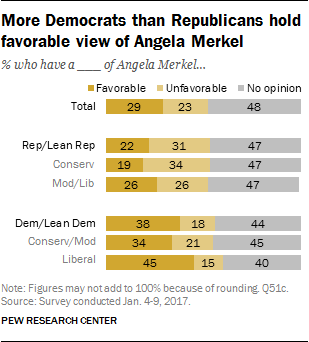Highlight a few significant elements in this photo. The distribution of favorable and unfavorable views among Liberal individuals is 60%. The highest value of the yellow bar is 45. 